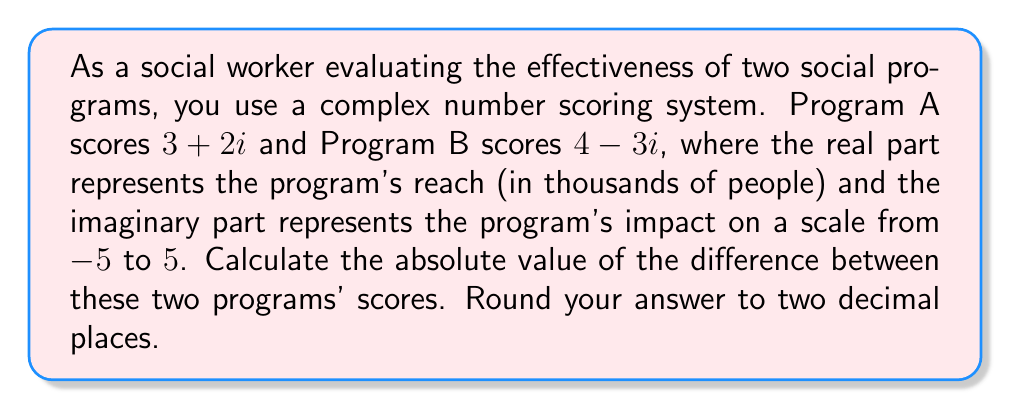Can you answer this question? To solve this problem, we need to follow these steps:

1) The scores of the two programs are:
   Program A: $z_1 = 3+2i$
   Program B: $z_2 = 4-3i$

2) We need to find the difference between these two complex numbers:
   $z = z_2 - z_1 = (4-3i) - (3+2i) = 4-3i-3-2i = 1-5i$

3) Now, we need to calculate the absolute value (or modulus) of this difference. For a complex number $a+bi$, the absolute value is given by the formula:

   $|a+bi| = \sqrt{a^2 + b^2}$

4) In our case, $a=1$ and $b=-5$. Let's substitute these into the formula:

   $|1-5i| = \sqrt{1^2 + (-5)^2} = \sqrt{1 + 25} = \sqrt{26}$

5) Calculate the square root:
   $\sqrt{26} \approx 5.0990$

6) Rounding to two decimal places:
   $5.0990 \approx 5.10$
Answer: $5.10$ 